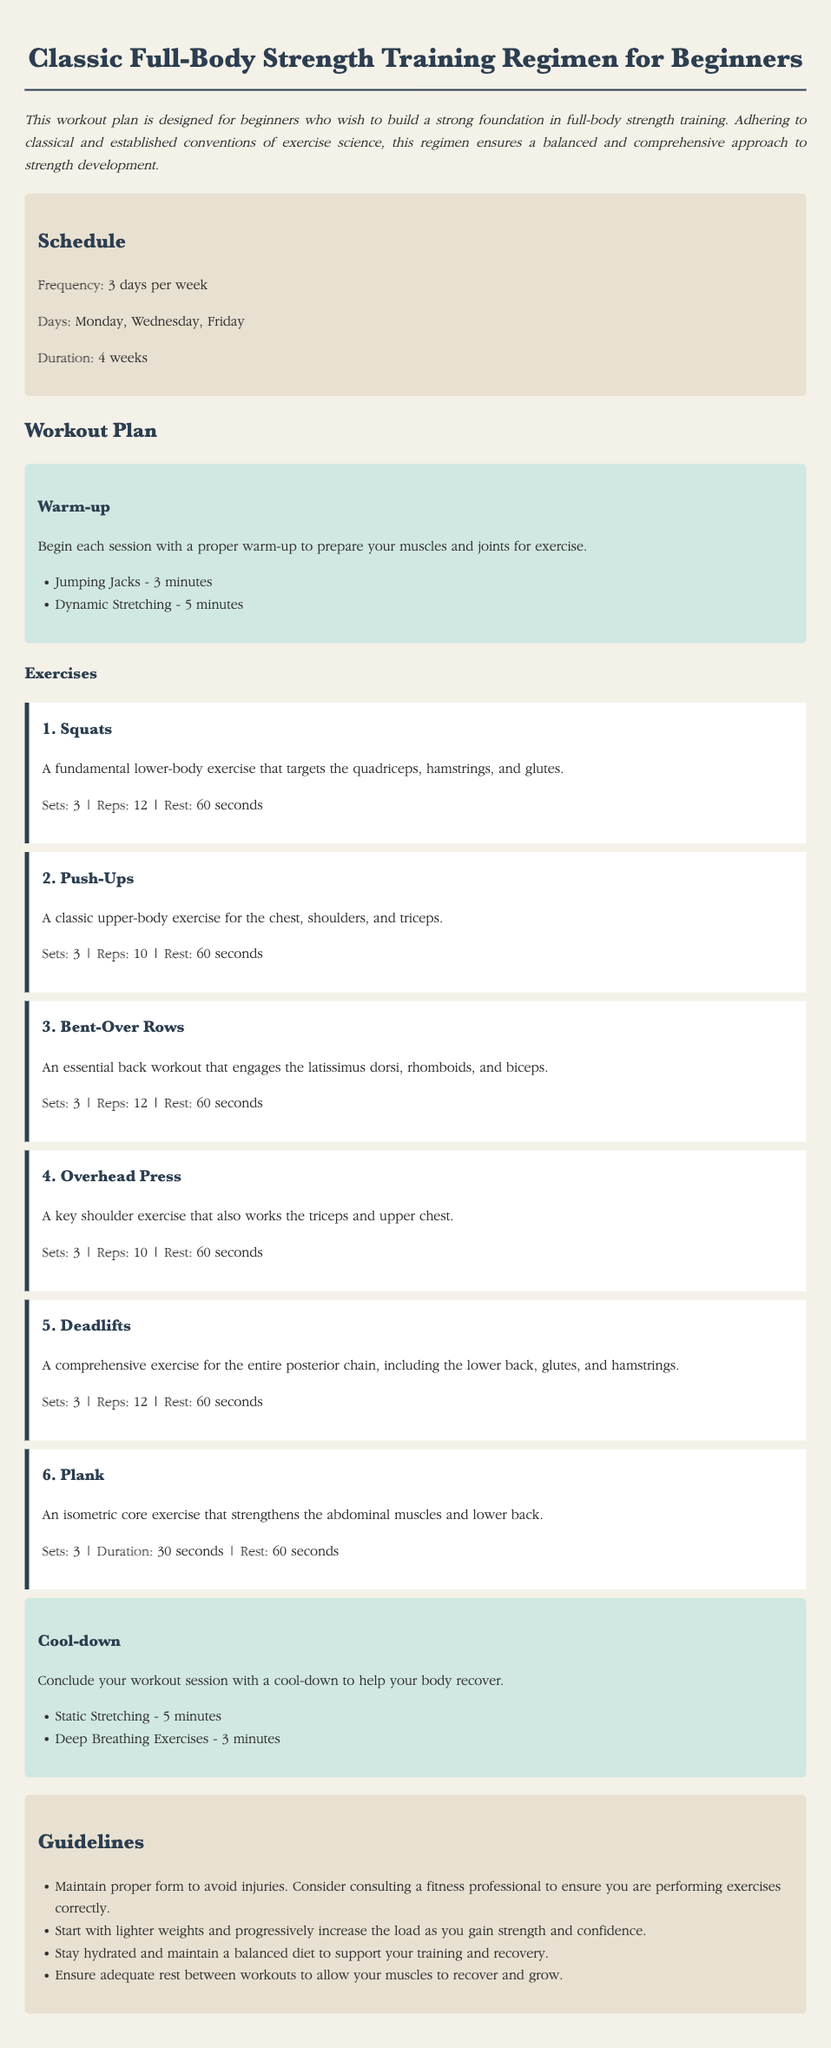What is the frequency of the workouts? The frequency of the workouts is mentioned in the schedule section, indicating how many times the workout plan should be performed each week.
Answer: 3 days per week On which days should the workouts be performed? The specific days for performing the workouts are provided in the document under the schedule section.
Answer: Monday, Wednesday, Friday How long is the duration of the workout plan? The total duration for following the workout plan is stated clearly in the schedule section.
Answer: 4 weeks What is the first exercise in the workout plan? The first exercise is listed in sequence within the exercise section of the workout plan.
Answer: Squats What type of exercise is a Plank? The document describes the Plank exercise in the workout section, stating its nature and the benefits it provides.
Answer: An isometric core exercise How many sets of Push-Ups should be performed? The required number of sets for performing Push-Ups is specified within the description of the exercise.
Answer: 3 Why is it important to maintain proper form? The guidelines section of the document provides rationale for the importance of maintaining proper exercise form.
Answer: To avoid injuries What is recommended to do before starting the workout session? The warm-up section lists activities that should be performed prior to beginning the workout.
Answer: Warm-up 